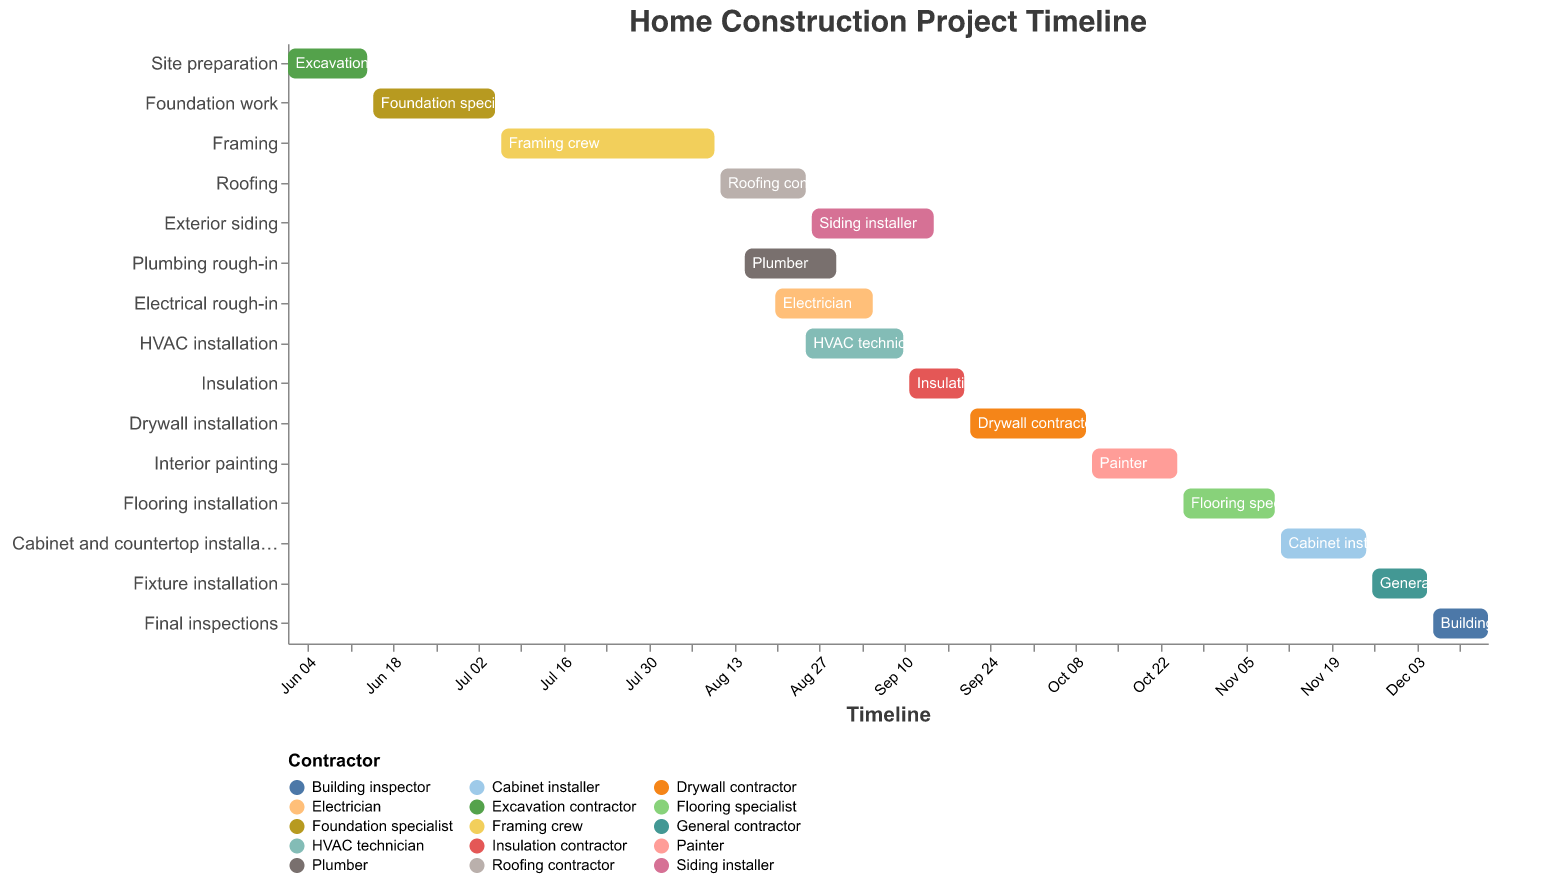What is the duration of the "Site preparation" phase? The "Site preparation" phase starts on June 1, 2023, and ends on June 14, 2023. To find the duration, calculate the number of days between the start and end dates.
Answer: 14 days Which contractor is responsible for the "HVAC installation" phase? The Gantt chart shows "HVAC installation" happening from August 25, 2023, to September 10, 2023, under the "HVAC technician" resource.
Answer: HVAC technician How many days does the "Drywall installation" phase take? "Drywall installation" starts on September 21, 2023, and ends on October 10, 2023. Counting all days in between (inclusive) gives the duration.
Answer: 20 days Which phases overlap with the "Plumbing rough-in" phase? "Plumbing rough-in" runs from August 15 to August 30, 2023. "Roofing" (August 11 - 25), "Electrical rough-in" (August 20 - September 5), and "HVAC installation" (August 25 - September 10) overlap.
Answer: Roofing, Electrical rough-in, HVAC installation How long is the total timeline for the construction project? The project starts with "Site preparation" on June 1, 2023, and ends with "Final inspections" on December 15, 2023. Counting all days in between gives the total timeline.
Answer: 198 days How many phases are handled by different specialist contractors (i.e., not the general contractor)? Every phase has a unique contractor except "Fixture installation" (handled by the general contractor). Count the distinct specialists.
Answer: 14 phases Which tasks finish in September 2023? The Gantt chart shows that "Exterior siding" ends on September 15, 2023, and "HVAC installation" ends on September 10, 2023. "Insulation" ends on September 20, 2023.
Answer: Exterior siding, HVAC installation, Insulation Which phase has the shortest duration, and what is it? Examine each task's duration by subtracting the start date from the end date. The phase with the fewest days is the shortest.
Answer: Fixture installation (10 days) What is the duration overlap between "Electrical rough-in" and "HVAC installation"? "Electrical rough-in" is from August 20 to September 5, and "HVAC installation" is from August 25 to September 10. Calculate the overlapping days.
Answer: 12 days When does "Cabinet and countertop installation" start? The Gantt chart shows that "Cabinet and countertop installation" starts on November 11, 2023.
Answer: November 11, 2023 